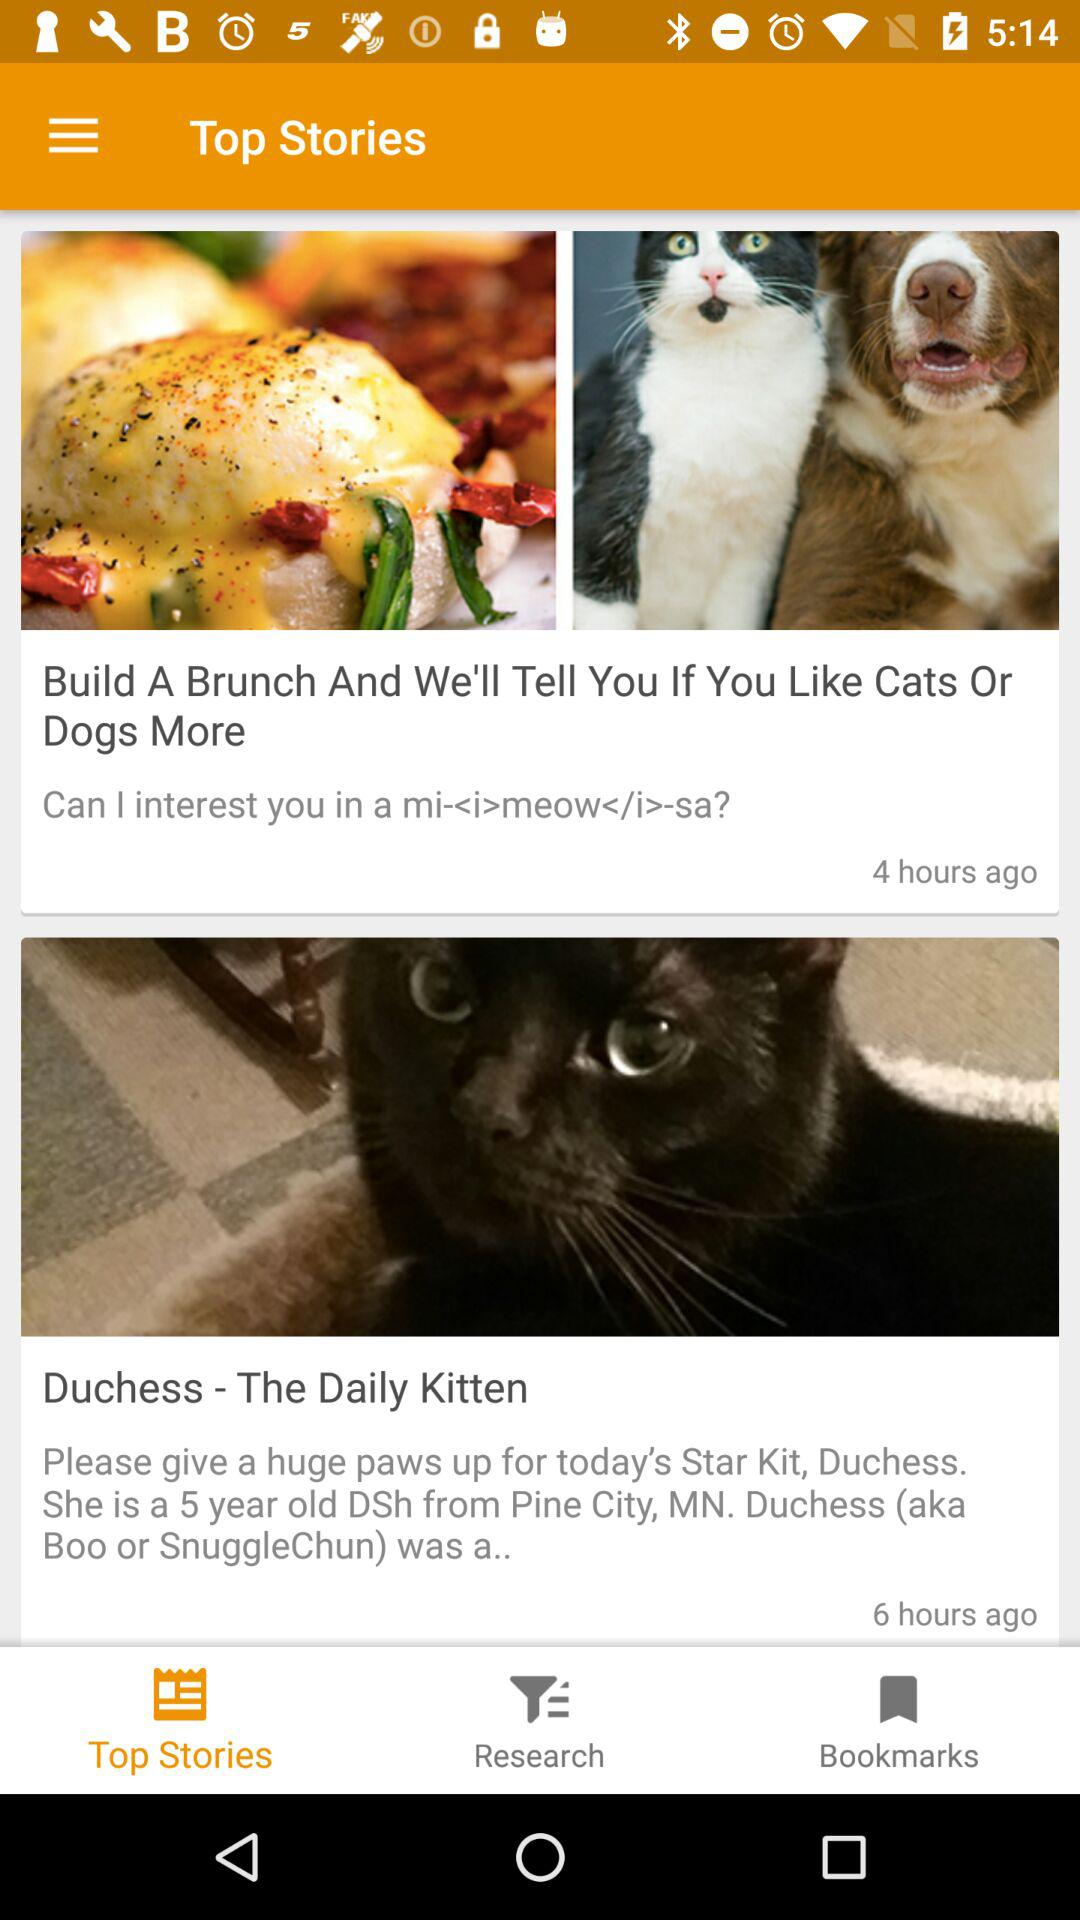What's the age of Duchess? Duchess is five years old. 